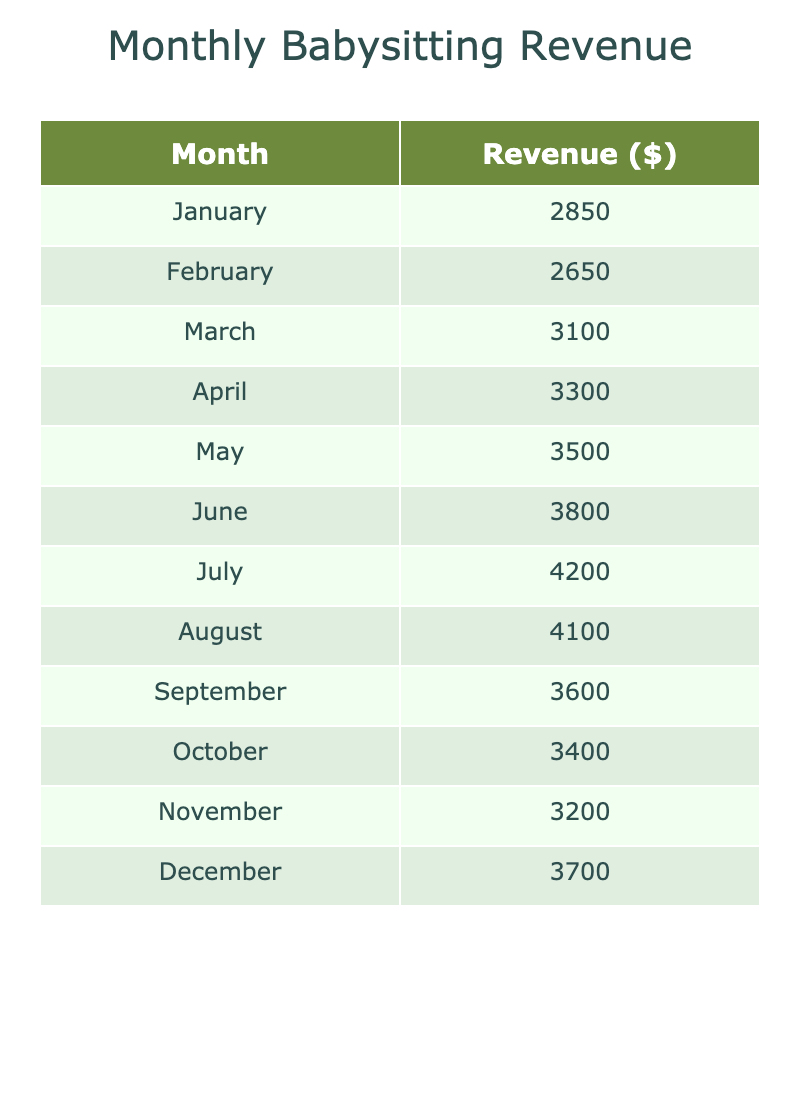What was the revenue in July? The table shows the revenue for each month. Looking at July, the revenue is listed as $4200.
Answer: $4200 Which month had the highest revenue? By analyzing the revenue figures, July has the highest revenue at $4200 compared to other months.
Answer: July What was the average monthly revenue over the year? To find the average, sum all the monthly revenues ($2850 + $2650 + $3100 + $3300 + $3500 + $3800 + $4200 + $4100 + $3600 + $3400 + $3200 + $3700 = $40,400) and divide by 12 (months), resulting in an average of $3366.67.
Answer: $3366.67 Was the revenue in December higher than in January? The revenue for December is $3700 and for January it is $2850. Since $3700 is greater than $2850, the statement is true.
Answer: Yes What revenue increase did I see from August to September? The revenue in August is $4100 and in September it is $3600. To find the increase or decrease, subtract September's revenue from August's ($3600 - $4100 = -$500), indicating a decrease.
Answer: Decrease of $500 What months had revenue above $3500? The months with revenue above $3500 are June ($3800), July ($4200), August ($4100), and May ($3500) too. Count these months to see that there are four instances.
Answer: Four months What was the total revenue from March to June? Adding the revenues from March to June involves summing these figures: $3100 (March) + $3300 (April) + $3500 (May) + $3800 (June). The total is $3100 + $3300 + $3500 + $3800 = $13,700.
Answer: $13,700 Did the revenue trend upward from January to July? By examining the monthly revenues, we see a consistent increase from $2850 in January to $4200 in July, indicating a clear upward trend.
Answer: Yes What was the difference in revenue between the highest and lowest months? Identify the highest revenue ($4200 in July) and the lowest revenue ($2650 in February) and subtract the lowest from the highest: $4200 - $2650 = $1550.
Answer: $1550 How many months had revenue below the average monthly revenue? The average monthly revenue is $3366.67. By examining the table, January ($2850), February ($2650), March ($3100), and November ($3200) have revenues below this average. This totals four months.
Answer: Four months 